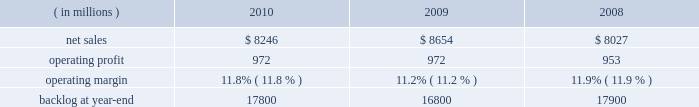Operating profit for the segment decreased by 1% ( 1 % ) in 2010 compared to 2009 .
For the year , operating profit declines in defense more than offset an increase in civil , while operating profit at intelligence essentially was unchanged .
The $ 27 million decrease in operating profit at defense primarily was attributable to a decrease in the level of favorable performance adjustments on mission and combat systems activities in 2010 .
The $ 19 million increase in civil principally was due to higher volume on enterprise civilian services .
Operating profit for the segment decreased by 3% ( 3 % ) in 2009 compared to 2008 .
Operating profit declines in civil and intelligence partially were offset by growth in defense .
The decrease of $ 29 million in civil 2019s operating profit primarily was attributable to a reduction in the level of favorable performance adjustments on enterprise civilian services programs in 2009 compared to 2008 .
The decrease in operating profit of $ 27 million at intelligence mainly was due to a reduction in the level of favorable performance adjustments on security solution activities in 2009 compared to 2008 .
The increase in defense 2019s operating profit of $ 29 million mainly was due to volume and improved performance in mission and combat systems .
The decrease in backlog during 2010 compared to 2009 mainly was due to higher sales volume on enterprise civilian service programs at civil , including volume associated with the dris 2010 program , and mission and combat system programs at defense .
Backlog decreased in 2009 compared to 2008 due to u.s .
Government 2019s exercise of the termination for convenience clause on the tsat mission operations system ( tmos ) contract at defense , which resulted in a $ 1.6 billion reduction in orders .
This decline more than offset increased orders on enterprise civilian services programs at civil .
We expect is&gs will experience a low single digit percentage decrease in sales for 2011 as compared to 2010 .
This decline primarily is due to completion of most of the work associated with the dris 2010 program .
Operating profit in 2011 is expected to decline in relationship to the decline in sales volume , while operating margins are expected to be comparable between the years .
Space systems our space systems business segment is engaged in the design , research and development , engineering , and production of satellites , strategic and defensive missile systems , and space transportation systems , including activities related to the planned replacement of the space shuttle .
Government satellite programs include the advanced extremely high frequency ( aehf ) system , the mobile user objective system ( muos ) , the global positioning satellite iii ( gps iii ) system , the space-based infrared system ( sbirs ) , and the geostationary operational environmental satellite r-series ( goes-r ) .
Strategic and missile defense programs include the targets and countermeasures program and the fleet ballistic missile program .
Space transportation includes the nasa orion program and , through ownership interests in two joint ventures , expendable launch services ( united launch alliance , or ula ) and space shuttle processing activities for the u.s .
Government ( united space alliance , or usa ) .
The space shuttle is expected to complete its final flight mission in 2011 and our involvement with its launch and processing activities will end at that time .
Space systems 2019 operating results included the following : ( in millions ) 2010 2009 2008 .
Net sales for space systems decreased by 5% ( 5 % ) in 2010 compared to 2009 .
Sales declined in all three lines of business during the year .
The $ 253 million decrease in space transportation principally was due to lower volume on the space shuttle external tank , commercial launch vehicle activity and other human space flight programs , which partially were offset by higher volume on the orion program .
There were no commercial launches in 2010 compared to one commercial launch in 2009 .
Strategic & defensive missile systems ( s&dms ) sales declined $ 147 million principally due to lower volume on defensive missile programs .
The $ 8 million sales decline in satellites primarily was attributable to lower volume on commercial satellites , which partially were offset by higher volume on government satellite activities .
There was one commercial satellite delivery in 2010 and one commercial satellite delivery in 2009 .
Net sales for space systems increased 8% ( 8 % ) in 2009 compared to 2008 .
During the year , sales growth at satellites and space transportation offset a decline in s&dms .
The sales growth of $ 707 million in satellites was due to higher volume in government satellite activities , which partially was offset by lower volume in commercial satellite activities .
There was one commercial satellite delivery in 2009 and two deliveries in 2008 .
The increase in sales of $ 21 million in space transportation primarily was due to higher volume on the orion program , which more than offset a decline in the space shuttle 2019s external tank program .
There was one commercial launch in both 2009 and 2008 .
S&dms 2019 sales decreased by $ 102 million mainly due to lower volume on defensive missile programs , which more than offset growth in strategic missile programs. .
What were average net sales for space systems in millions from 2008 to 2010? 
Computations: table_average(net sales, none)
Answer: 8309.0. 